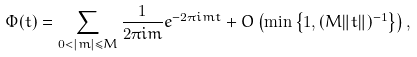<formula> <loc_0><loc_0><loc_500><loc_500>\Phi ( t ) = \sum _ { 0 < | m | \leq M } \frac { 1 } { 2 \pi i m } e ^ { - 2 \pi i m t } + O \left ( \min \left \{ 1 , { ( M \| t \| ) ^ { - 1 } } \right \} \right ) ,</formula> 